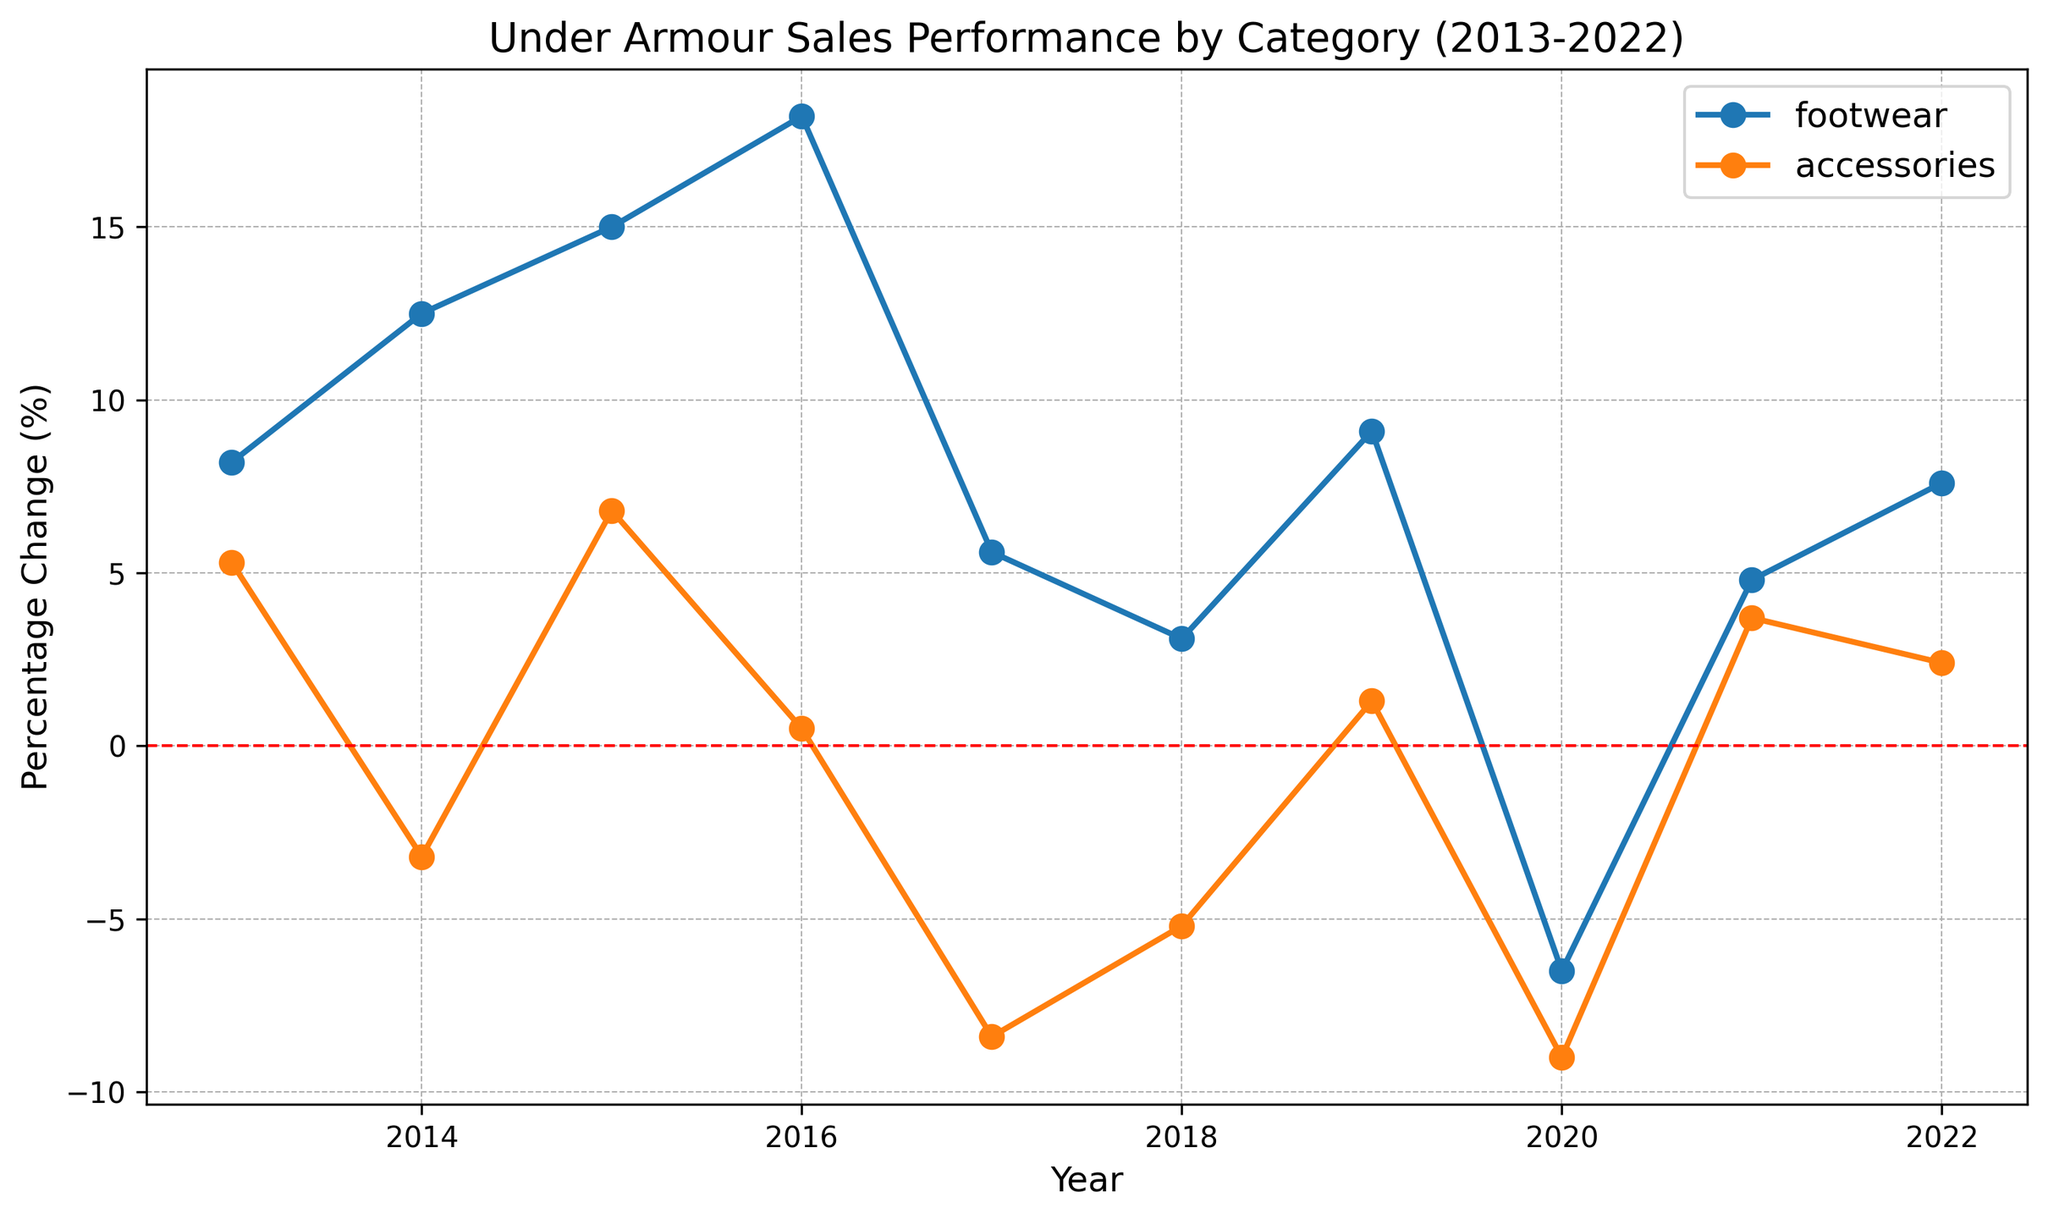What year did both footwear and accessories categories have negative percentage changes? To find the year when both categories had negative changes, look at the years where the lines for both categories are below zero (the horizontal red line). In 2020, both the footwear (-6.5%) and accessories (-9.0%) had negative percentage changes.
Answer: 2020 Which category had the highest percentage change in any given year? Look at the highest point of each line in the chart. The highest peak in the chart is for the footwear category in 2016, with a percentage change of 18.2%.
Answer: Footwear Between 2017 and 2018, which category saw an increase in percentage change while the other saw a decrease? From 2017 to 2018, the footwear category's line goes downward from 5.6% to 3.1%, indicating a decrease. Conversely, the accessories category's line goes upward from -8.4% to -5.2%, indicating an increase.
Answer: Accessories Comparing the percentage changes in 2013 and 2022, how much did the percentage change increase or decrease for the accessories category? In 2013, the accessories category had a percentage change of 5.3%. By 2022, the percentage change was 2.4%. The change is calculated as 2.4% - 5.3% = -2.9%. Thus, the percentage change decreased by 2.9%.
Answer: Decreased by 2.9% During which period did the footwear category see its largest single-year increase in percentage change? Look for the steepest upward slope in the footwear line. The largest increase is from 2015 (15.0%) to 2016 (18.2%), resulting in an increase of 3.2%.
Answer: 2015-2016 In how many years did the accessories category have a percentage change greater than 5%? Look at the points on the accessories line that are above the 5% horizontal axis. In 2013 it has a percentage change of 5.3%, and in 2015 it is 6.8%. Thus, it occurred in two years.
Answer: 2 years Which year and category combination had the lowest percentage change on the chart? To find the lowest point, look at the lowest values of both lines. The lowest point on the chart is for the accessories category in 2020, with a percentage change of -9.0%.
Answer: Accessories in 2020 Across the entire decade, which category had more years with negative growth? Count the points below the zero line for each category. Footwear has one year (2020), whereas accessories have three years (2014, 2017, 2018, and 2020). Thus, accessories had more years with negative growth.
Answer: Accessories On average, how did the percentage change for the footwear category compare to the accessories category across all the years shown? Calculate the average percentage change for each category by averaging their percentage changes: Footwear: (8.2 + 12.5 + 15.0 + 18.2 + 5.6 + 3.1 + 9.1 - 6.5 + 4.8 + 7.6) / 10 = 7.76%, Accessories: (5.3 - 3.2 + 6.8 + 0.5 - 8.4 - 5.2 + 1.3 - 9.0 + 3.7 + 2.4) / 10 = -0.58%, showing the footwear category had a higher average percentage change.
Answer: Footwear had a higher average percentage change 